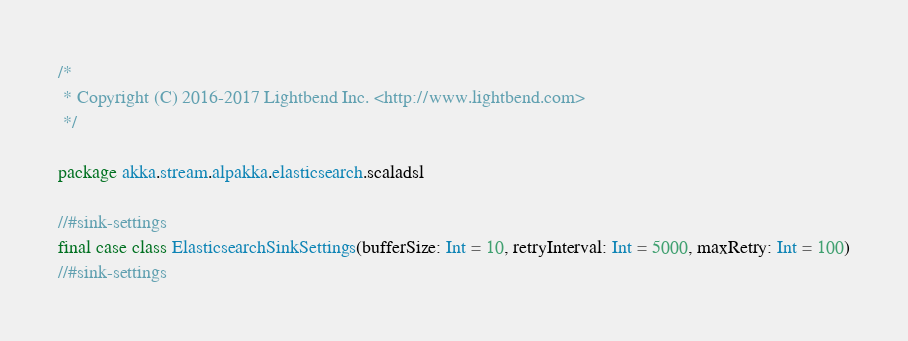<code> <loc_0><loc_0><loc_500><loc_500><_Scala_>/*
 * Copyright (C) 2016-2017 Lightbend Inc. <http://www.lightbend.com>
 */

package akka.stream.alpakka.elasticsearch.scaladsl

//#sink-settings
final case class ElasticsearchSinkSettings(bufferSize: Int = 10, retryInterval: Int = 5000, maxRetry: Int = 100)
//#sink-settings
</code> 